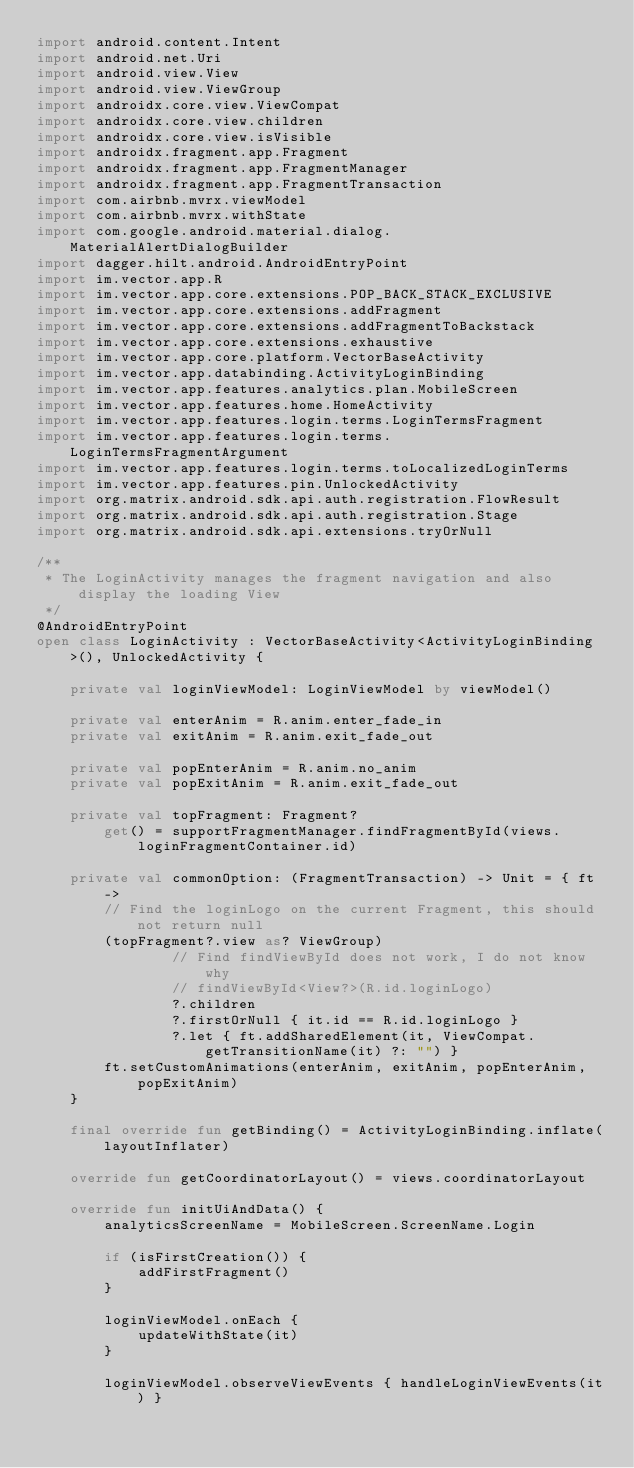Convert code to text. <code><loc_0><loc_0><loc_500><loc_500><_Kotlin_>import android.content.Intent
import android.net.Uri
import android.view.View
import android.view.ViewGroup
import androidx.core.view.ViewCompat
import androidx.core.view.children
import androidx.core.view.isVisible
import androidx.fragment.app.Fragment
import androidx.fragment.app.FragmentManager
import androidx.fragment.app.FragmentTransaction
import com.airbnb.mvrx.viewModel
import com.airbnb.mvrx.withState
import com.google.android.material.dialog.MaterialAlertDialogBuilder
import dagger.hilt.android.AndroidEntryPoint
import im.vector.app.R
import im.vector.app.core.extensions.POP_BACK_STACK_EXCLUSIVE
import im.vector.app.core.extensions.addFragment
import im.vector.app.core.extensions.addFragmentToBackstack
import im.vector.app.core.extensions.exhaustive
import im.vector.app.core.platform.VectorBaseActivity
import im.vector.app.databinding.ActivityLoginBinding
import im.vector.app.features.analytics.plan.MobileScreen
import im.vector.app.features.home.HomeActivity
import im.vector.app.features.login.terms.LoginTermsFragment
import im.vector.app.features.login.terms.LoginTermsFragmentArgument
import im.vector.app.features.login.terms.toLocalizedLoginTerms
import im.vector.app.features.pin.UnlockedActivity
import org.matrix.android.sdk.api.auth.registration.FlowResult
import org.matrix.android.sdk.api.auth.registration.Stage
import org.matrix.android.sdk.api.extensions.tryOrNull

/**
 * The LoginActivity manages the fragment navigation and also display the loading View
 */
@AndroidEntryPoint
open class LoginActivity : VectorBaseActivity<ActivityLoginBinding>(), UnlockedActivity {

    private val loginViewModel: LoginViewModel by viewModel()

    private val enterAnim = R.anim.enter_fade_in
    private val exitAnim = R.anim.exit_fade_out

    private val popEnterAnim = R.anim.no_anim
    private val popExitAnim = R.anim.exit_fade_out

    private val topFragment: Fragment?
        get() = supportFragmentManager.findFragmentById(views.loginFragmentContainer.id)

    private val commonOption: (FragmentTransaction) -> Unit = { ft ->
        // Find the loginLogo on the current Fragment, this should not return null
        (topFragment?.view as? ViewGroup)
                // Find findViewById does not work, I do not know why
                // findViewById<View?>(R.id.loginLogo)
                ?.children
                ?.firstOrNull { it.id == R.id.loginLogo }
                ?.let { ft.addSharedElement(it, ViewCompat.getTransitionName(it) ?: "") }
        ft.setCustomAnimations(enterAnim, exitAnim, popEnterAnim, popExitAnim)
    }

    final override fun getBinding() = ActivityLoginBinding.inflate(layoutInflater)

    override fun getCoordinatorLayout() = views.coordinatorLayout

    override fun initUiAndData() {
        analyticsScreenName = MobileScreen.ScreenName.Login

        if (isFirstCreation()) {
            addFirstFragment()
        }

        loginViewModel.onEach {
            updateWithState(it)
        }

        loginViewModel.observeViewEvents { handleLoginViewEvents(it) }
</code> 